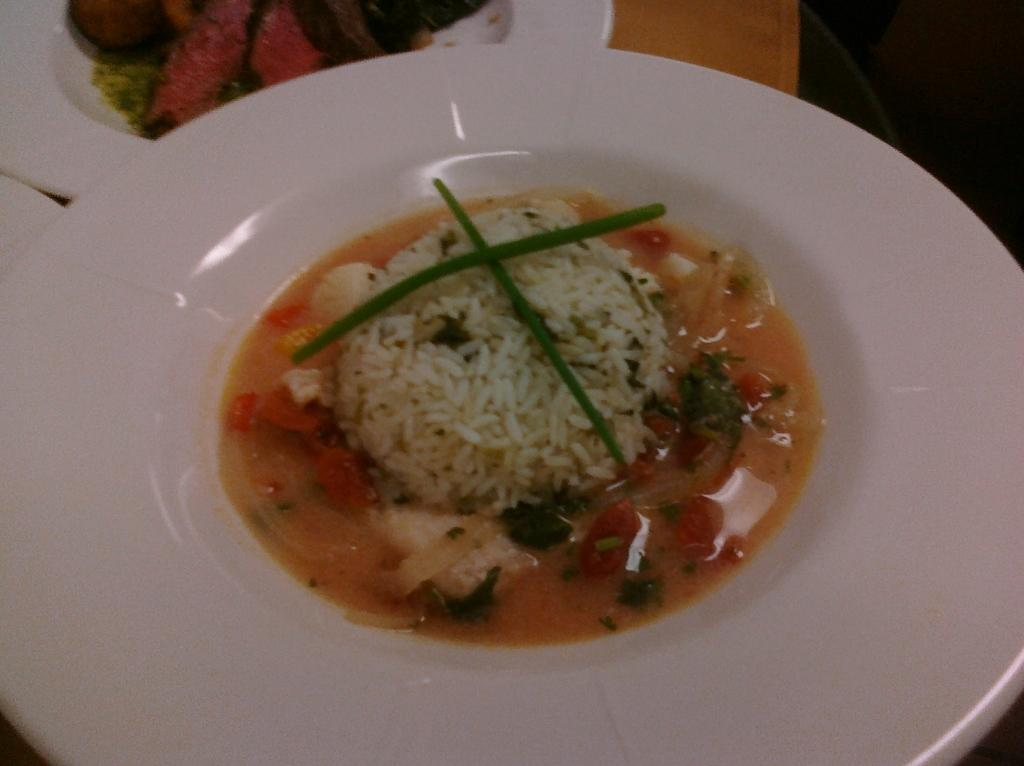What objects are present on the table in the image? There are plates in the image. What is on the plates? The plates contain food. Where are the plates located? The plates are placed on a table. What type of letters are being written by the judge in the image? There is no judge or letters present in the image; it only features plates with food on a table. 